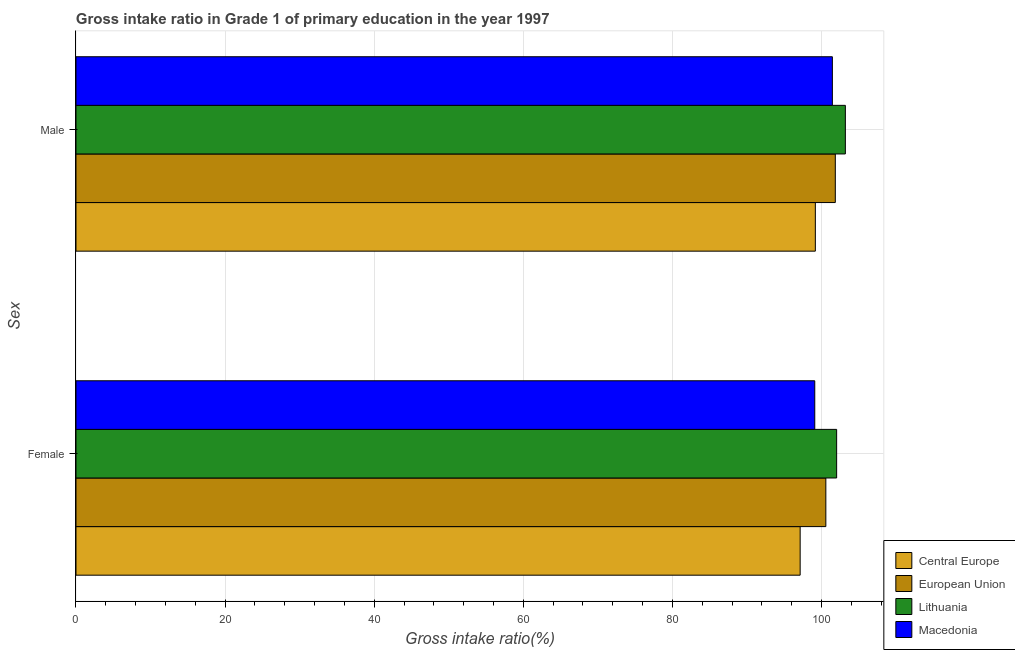How many different coloured bars are there?
Your response must be concise. 4. How many groups of bars are there?
Your answer should be very brief. 2. Are the number of bars per tick equal to the number of legend labels?
Offer a very short reply. Yes. Are the number of bars on each tick of the Y-axis equal?
Give a very brief answer. Yes. What is the gross intake ratio(male) in European Union?
Make the answer very short. 101.85. Across all countries, what is the maximum gross intake ratio(male)?
Offer a very short reply. 103.2. Across all countries, what is the minimum gross intake ratio(female)?
Provide a short and direct response. 97.14. In which country was the gross intake ratio(male) maximum?
Give a very brief answer. Lithuania. In which country was the gross intake ratio(female) minimum?
Your response must be concise. Central Europe. What is the total gross intake ratio(male) in the graph?
Give a very brief answer. 405.69. What is the difference between the gross intake ratio(female) in European Union and that in Lithuania?
Ensure brevity in your answer.  -1.45. What is the difference between the gross intake ratio(male) in Lithuania and the gross intake ratio(female) in Macedonia?
Give a very brief answer. 4.1. What is the average gross intake ratio(male) per country?
Your answer should be very brief. 101.42. What is the difference between the gross intake ratio(male) and gross intake ratio(female) in Macedonia?
Keep it short and to the point. 2.36. What is the ratio of the gross intake ratio(female) in Macedonia to that in Lithuania?
Ensure brevity in your answer.  0.97. In how many countries, is the gross intake ratio(female) greater than the average gross intake ratio(female) taken over all countries?
Keep it short and to the point. 2. What does the 4th bar from the top in Male represents?
Your answer should be very brief. Central Europe. What does the 4th bar from the bottom in Female represents?
Ensure brevity in your answer.  Macedonia. How many countries are there in the graph?
Offer a very short reply. 4. What is the title of the graph?
Your answer should be compact. Gross intake ratio in Grade 1 of primary education in the year 1997. What is the label or title of the X-axis?
Keep it short and to the point. Gross intake ratio(%). What is the label or title of the Y-axis?
Provide a short and direct response. Sex. What is the Gross intake ratio(%) of Central Europe in Female?
Your response must be concise. 97.14. What is the Gross intake ratio(%) of European Union in Female?
Your response must be concise. 100.59. What is the Gross intake ratio(%) of Lithuania in Female?
Provide a succinct answer. 102.03. What is the Gross intake ratio(%) of Macedonia in Female?
Your response must be concise. 99.1. What is the Gross intake ratio(%) in Central Europe in Male?
Give a very brief answer. 99.18. What is the Gross intake ratio(%) in European Union in Male?
Provide a succinct answer. 101.85. What is the Gross intake ratio(%) in Lithuania in Male?
Your answer should be compact. 103.2. What is the Gross intake ratio(%) of Macedonia in Male?
Your response must be concise. 101.46. Across all Sex, what is the maximum Gross intake ratio(%) of Central Europe?
Your answer should be compact. 99.18. Across all Sex, what is the maximum Gross intake ratio(%) in European Union?
Keep it short and to the point. 101.85. Across all Sex, what is the maximum Gross intake ratio(%) in Lithuania?
Make the answer very short. 103.2. Across all Sex, what is the maximum Gross intake ratio(%) in Macedonia?
Offer a terse response. 101.46. Across all Sex, what is the minimum Gross intake ratio(%) in Central Europe?
Your answer should be very brief. 97.14. Across all Sex, what is the minimum Gross intake ratio(%) in European Union?
Provide a short and direct response. 100.59. Across all Sex, what is the minimum Gross intake ratio(%) in Lithuania?
Give a very brief answer. 102.03. Across all Sex, what is the minimum Gross intake ratio(%) of Macedonia?
Offer a terse response. 99.1. What is the total Gross intake ratio(%) of Central Europe in the graph?
Keep it short and to the point. 196.31. What is the total Gross intake ratio(%) in European Union in the graph?
Offer a terse response. 202.44. What is the total Gross intake ratio(%) of Lithuania in the graph?
Give a very brief answer. 205.23. What is the total Gross intake ratio(%) in Macedonia in the graph?
Your answer should be very brief. 200.56. What is the difference between the Gross intake ratio(%) of Central Europe in Female and that in Male?
Offer a terse response. -2.04. What is the difference between the Gross intake ratio(%) of European Union in Female and that in Male?
Your answer should be very brief. -1.27. What is the difference between the Gross intake ratio(%) of Lithuania in Female and that in Male?
Ensure brevity in your answer.  -1.17. What is the difference between the Gross intake ratio(%) of Macedonia in Female and that in Male?
Offer a very short reply. -2.36. What is the difference between the Gross intake ratio(%) of Central Europe in Female and the Gross intake ratio(%) of European Union in Male?
Offer a very short reply. -4.72. What is the difference between the Gross intake ratio(%) in Central Europe in Female and the Gross intake ratio(%) in Lithuania in Male?
Provide a short and direct response. -6.06. What is the difference between the Gross intake ratio(%) of Central Europe in Female and the Gross intake ratio(%) of Macedonia in Male?
Your answer should be very brief. -4.32. What is the difference between the Gross intake ratio(%) in European Union in Female and the Gross intake ratio(%) in Lithuania in Male?
Make the answer very short. -2.62. What is the difference between the Gross intake ratio(%) in European Union in Female and the Gross intake ratio(%) in Macedonia in Male?
Ensure brevity in your answer.  -0.87. What is the difference between the Gross intake ratio(%) in Lithuania in Female and the Gross intake ratio(%) in Macedonia in Male?
Provide a succinct answer. 0.57. What is the average Gross intake ratio(%) in Central Europe per Sex?
Your answer should be very brief. 98.16. What is the average Gross intake ratio(%) in European Union per Sex?
Provide a succinct answer. 101.22. What is the average Gross intake ratio(%) in Lithuania per Sex?
Give a very brief answer. 102.62. What is the average Gross intake ratio(%) of Macedonia per Sex?
Your answer should be compact. 100.28. What is the difference between the Gross intake ratio(%) in Central Europe and Gross intake ratio(%) in European Union in Female?
Offer a terse response. -3.45. What is the difference between the Gross intake ratio(%) of Central Europe and Gross intake ratio(%) of Lithuania in Female?
Your answer should be compact. -4.89. What is the difference between the Gross intake ratio(%) of Central Europe and Gross intake ratio(%) of Macedonia in Female?
Give a very brief answer. -1.96. What is the difference between the Gross intake ratio(%) of European Union and Gross intake ratio(%) of Lithuania in Female?
Your response must be concise. -1.45. What is the difference between the Gross intake ratio(%) of European Union and Gross intake ratio(%) of Macedonia in Female?
Offer a very short reply. 1.49. What is the difference between the Gross intake ratio(%) of Lithuania and Gross intake ratio(%) of Macedonia in Female?
Keep it short and to the point. 2.93. What is the difference between the Gross intake ratio(%) of Central Europe and Gross intake ratio(%) of European Union in Male?
Provide a succinct answer. -2.68. What is the difference between the Gross intake ratio(%) in Central Europe and Gross intake ratio(%) in Lithuania in Male?
Your answer should be compact. -4.03. What is the difference between the Gross intake ratio(%) of Central Europe and Gross intake ratio(%) of Macedonia in Male?
Offer a very short reply. -2.28. What is the difference between the Gross intake ratio(%) in European Union and Gross intake ratio(%) in Lithuania in Male?
Your response must be concise. -1.35. What is the difference between the Gross intake ratio(%) of European Union and Gross intake ratio(%) of Macedonia in Male?
Your response must be concise. 0.39. What is the difference between the Gross intake ratio(%) in Lithuania and Gross intake ratio(%) in Macedonia in Male?
Give a very brief answer. 1.74. What is the ratio of the Gross intake ratio(%) in Central Europe in Female to that in Male?
Offer a very short reply. 0.98. What is the ratio of the Gross intake ratio(%) of European Union in Female to that in Male?
Ensure brevity in your answer.  0.99. What is the ratio of the Gross intake ratio(%) in Lithuania in Female to that in Male?
Your answer should be compact. 0.99. What is the ratio of the Gross intake ratio(%) in Macedonia in Female to that in Male?
Keep it short and to the point. 0.98. What is the difference between the highest and the second highest Gross intake ratio(%) in Central Europe?
Provide a succinct answer. 2.04. What is the difference between the highest and the second highest Gross intake ratio(%) of European Union?
Keep it short and to the point. 1.27. What is the difference between the highest and the second highest Gross intake ratio(%) of Lithuania?
Provide a short and direct response. 1.17. What is the difference between the highest and the second highest Gross intake ratio(%) in Macedonia?
Make the answer very short. 2.36. What is the difference between the highest and the lowest Gross intake ratio(%) in Central Europe?
Offer a very short reply. 2.04. What is the difference between the highest and the lowest Gross intake ratio(%) of European Union?
Ensure brevity in your answer.  1.27. What is the difference between the highest and the lowest Gross intake ratio(%) in Lithuania?
Keep it short and to the point. 1.17. What is the difference between the highest and the lowest Gross intake ratio(%) of Macedonia?
Your answer should be very brief. 2.36. 